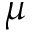Convert formula to latex. <formula><loc_0><loc_0><loc_500><loc_500>\mu</formula> 